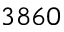<formula> <loc_0><loc_0><loc_500><loc_500>3 8 6 0</formula> 